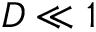Convert formula to latex. <formula><loc_0><loc_0><loc_500><loc_500>D \ll 1</formula> 